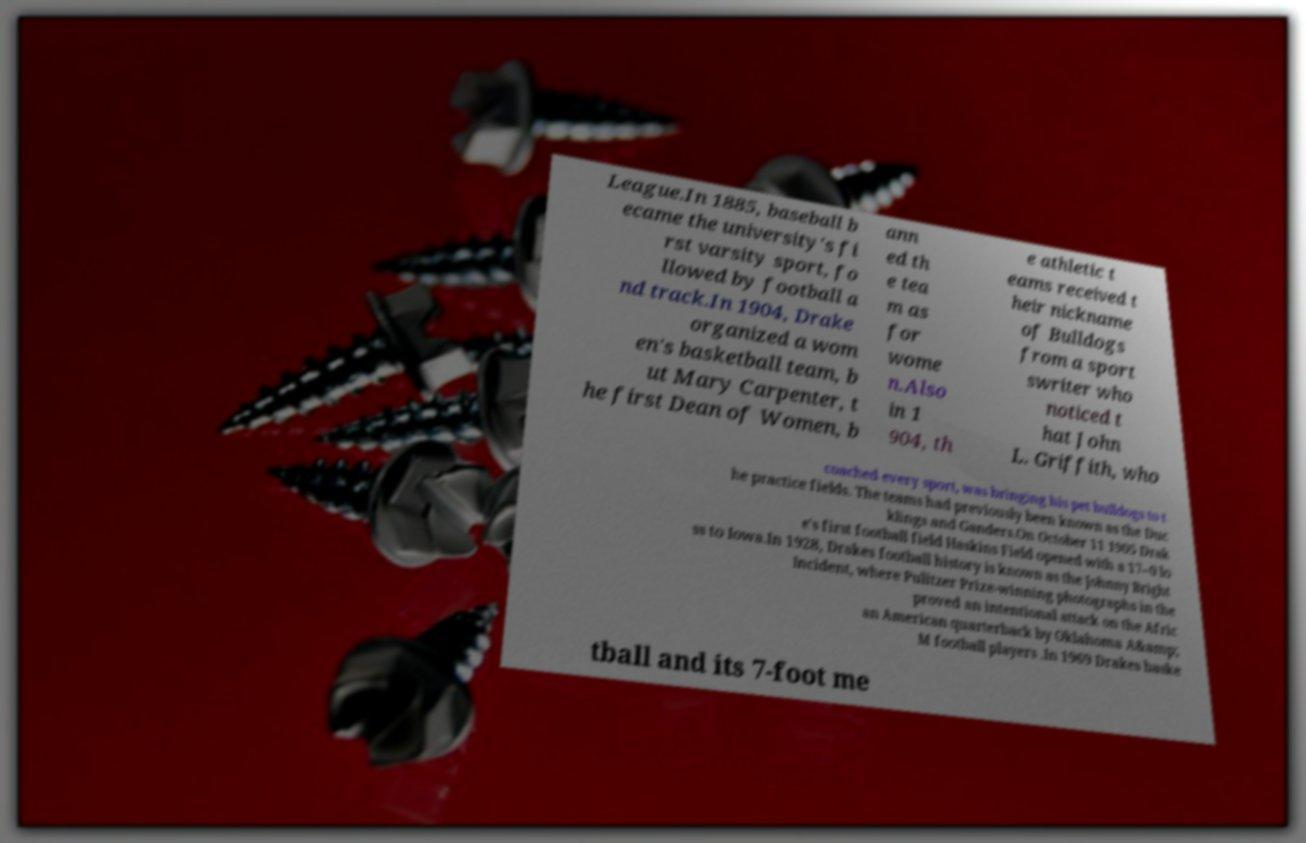Could you extract and type out the text from this image? League.In 1885, baseball b ecame the university's fi rst varsity sport, fo llowed by football a nd track.In 1904, Drake organized a wom en's basketball team, b ut Mary Carpenter, t he first Dean of Women, b ann ed th e tea m as for wome n.Also in 1 904, th e athletic t eams received t heir nickname of Bulldogs from a sport swriter who noticed t hat John L. Griffith, who coached every sport, was bringing his pet bulldogs to t he practice fields. The teams had previously been known as the Duc klings and Ganders.On October 11 1905 Drak e's first football field Haskins Field opened with a 17–0 lo ss to Iowa.In 1928, Drakes football history is known as the Johnny Bright Incident, where Pulitzer Prize-winning photographs in the proved an intentional attack on the Afric an American quarterback by Oklahoma A&amp; M football players .In 1969 Drakes baske tball and its 7-foot me 